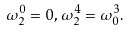Convert formula to latex. <formula><loc_0><loc_0><loc_500><loc_500>\omega _ { 2 } ^ { 0 } = 0 , \, \omega _ { 2 } ^ { 4 } = \omega _ { 0 } ^ { 3 } .</formula> 